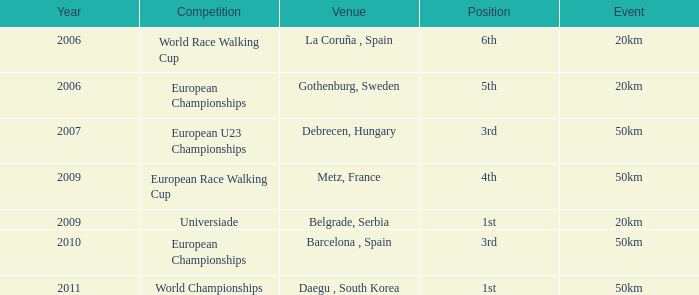What Position is listed against a Venue of Debrecen, Hungary 3rd. Help me parse the entirety of this table. {'header': ['Year', 'Competition', 'Venue', 'Position', 'Event'], 'rows': [['2006', 'World Race Walking Cup', 'La Coruña , Spain', '6th', '20km'], ['2006', 'European Championships', 'Gothenburg, Sweden', '5th', '20km'], ['2007', 'European U23 Championships', 'Debrecen, Hungary', '3rd', '50km'], ['2009', 'European Race Walking Cup', 'Metz, France', '4th', '50km'], ['2009', 'Universiade', 'Belgrade, Serbia', '1st', '20km'], ['2010', 'European Championships', 'Barcelona , Spain', '3rd', '50km'], ['2011', 'World Championships', 'Daegu , South Korea', '1st', '50km']]} 